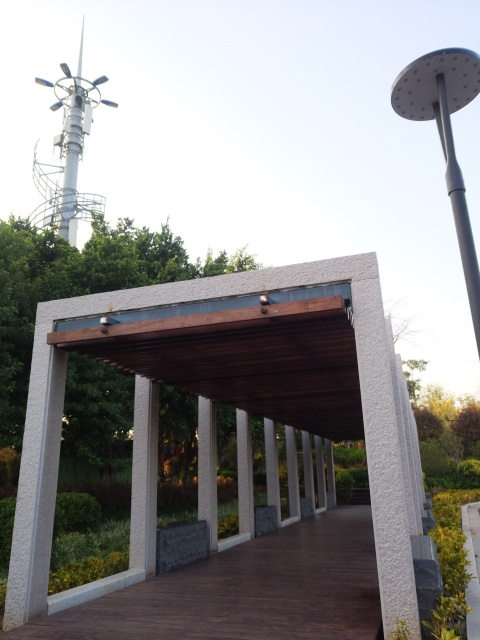Does the photo have high contrast? While the photo does present a distinction between light and shadow, particularly under the structure and in the foreground, the overall contrast is not particularly striking or intense. The scene’s contrast appears moderate as we can see a smooth transition between the darker and lighter areas, without extreme differences that would constitute high contrast. 